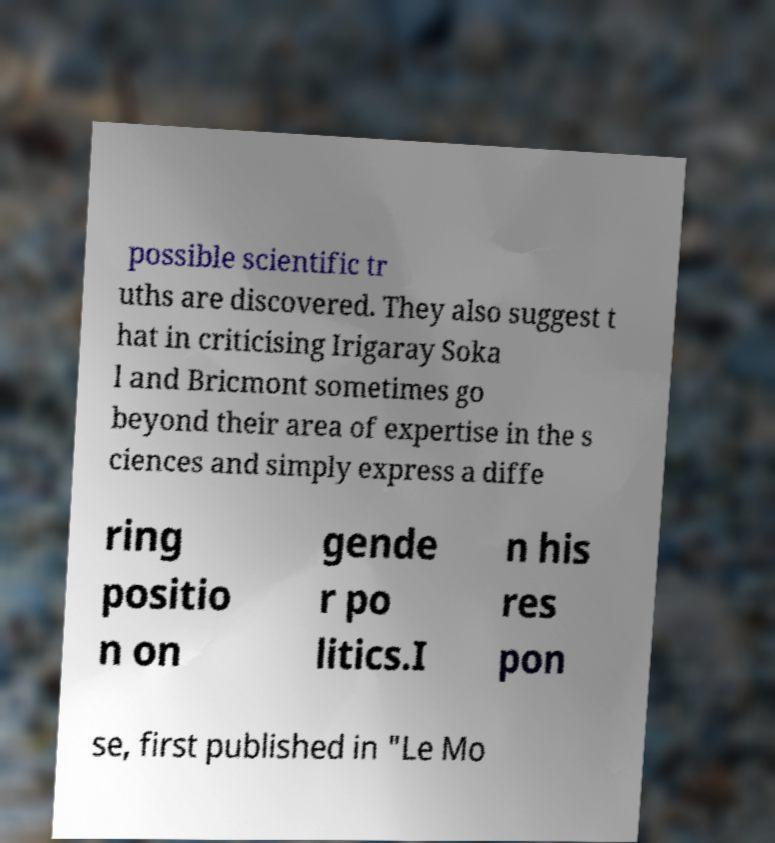Please identify and transcribe the text found in this image. possible scientific tr uths are discovered. They also suggest t hat in criticising Irigaray Soka l and Bricmont sometimes go beyond their area of expertise in the s ciences and simply express a diffe ring positio n on gende r po litics.I n his res pon se, first published in "Le Mo 